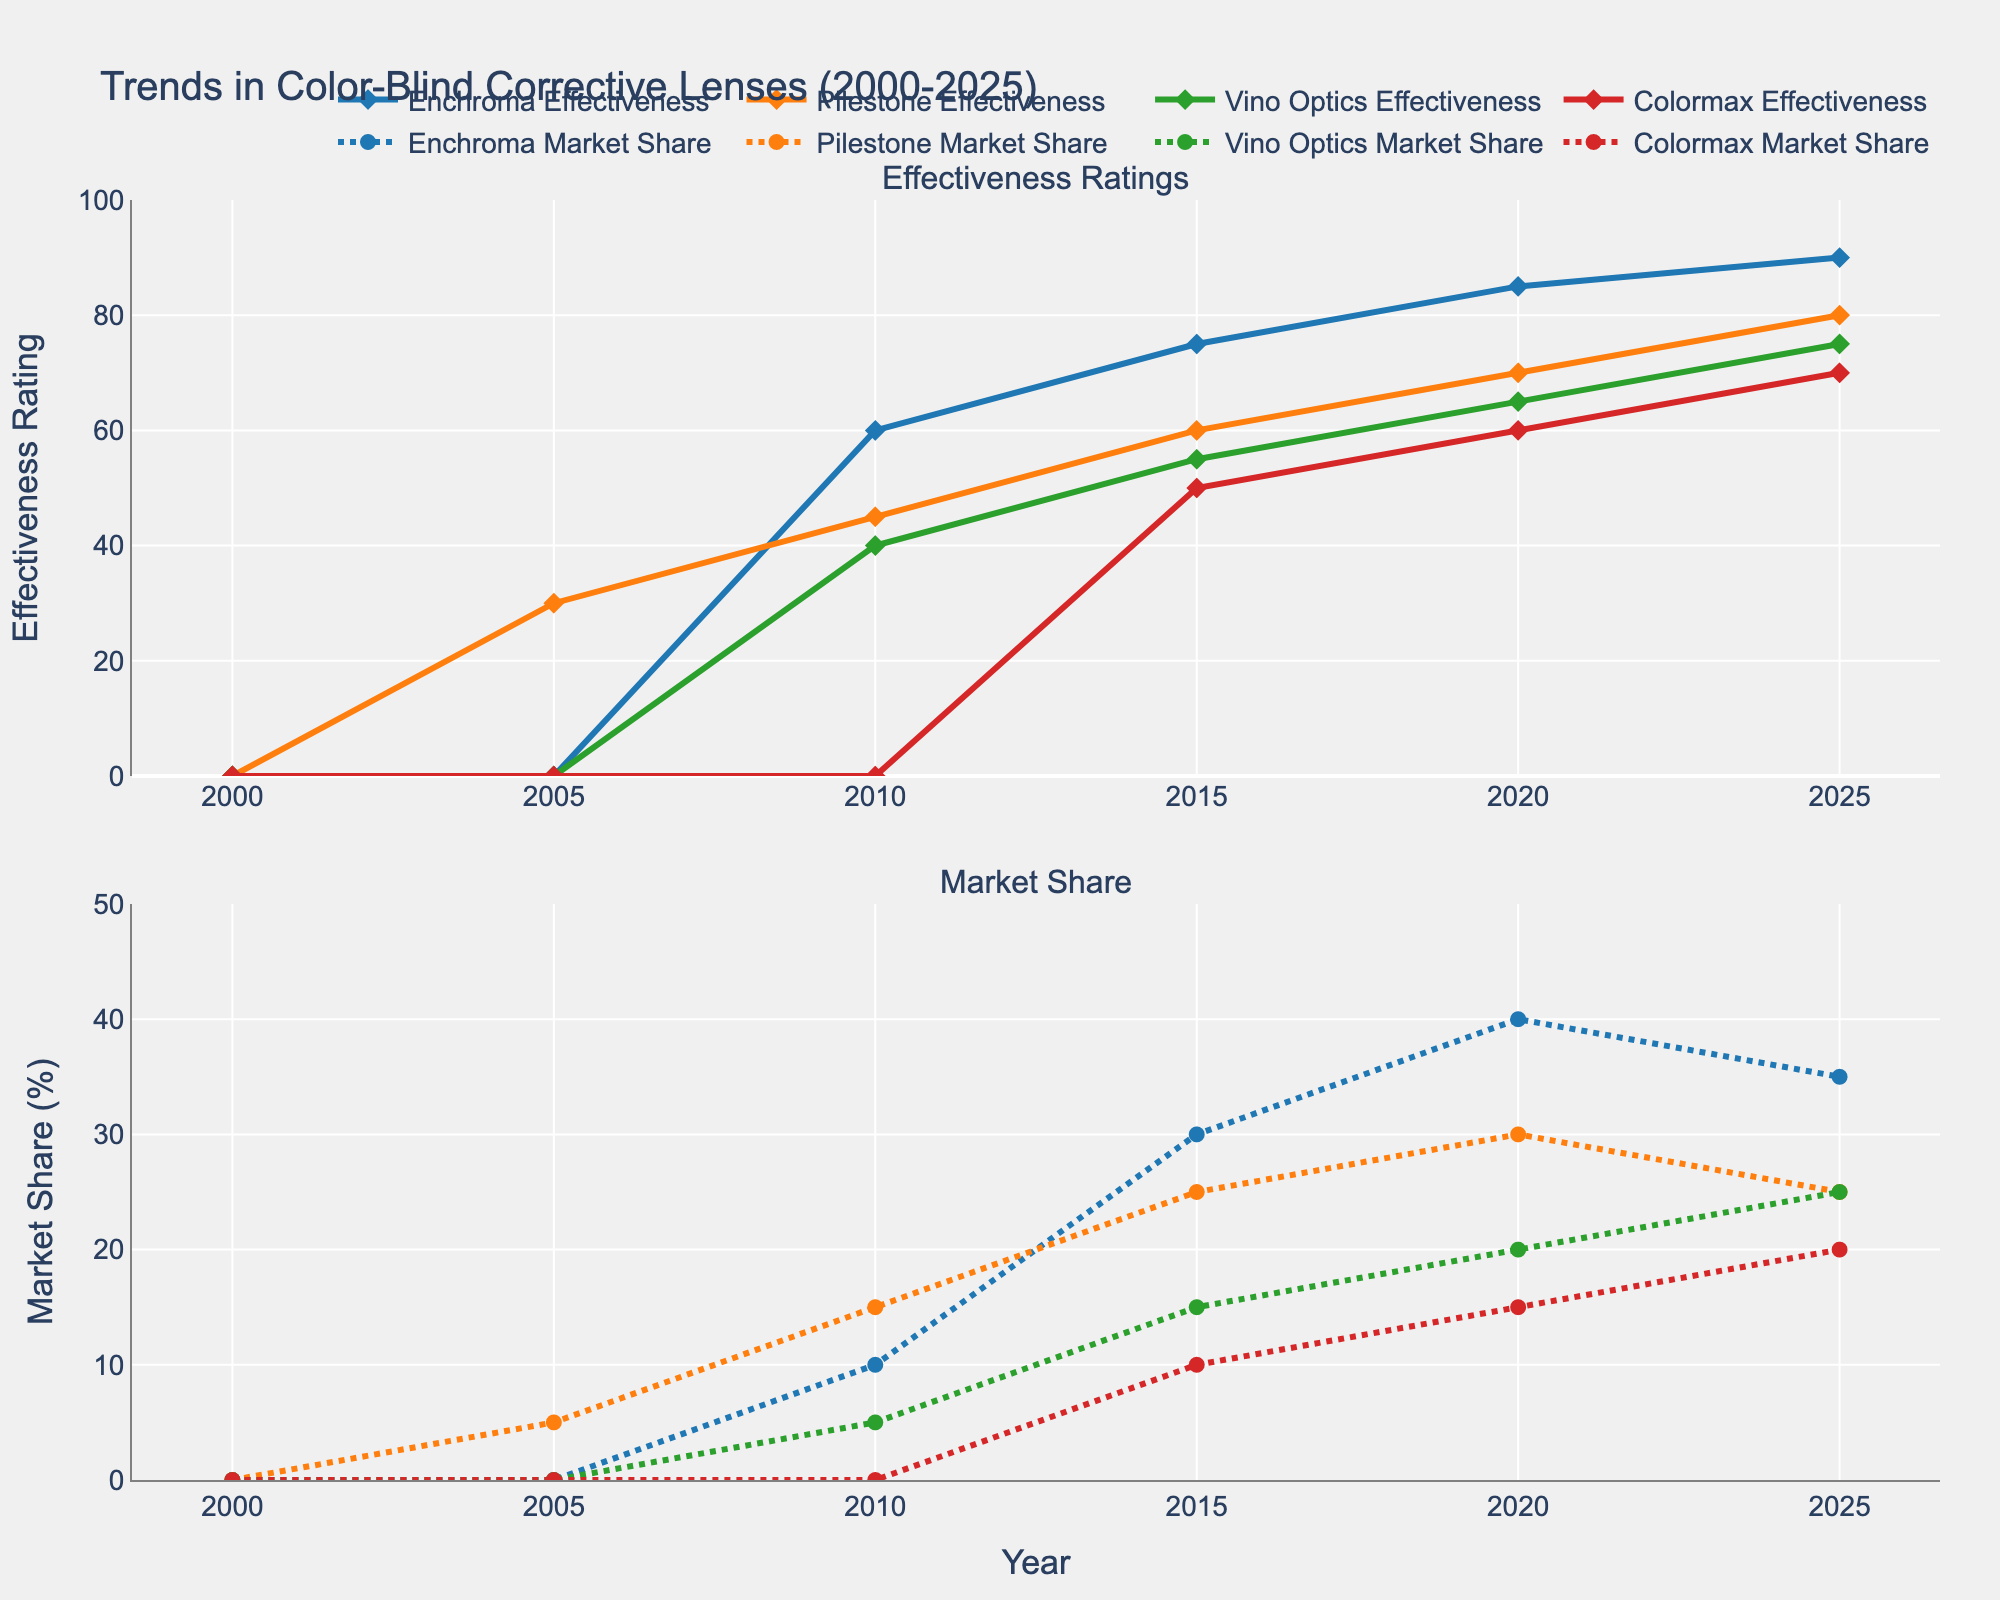What is the title of the figure? The title is displayed at the top of the figure and provides an overview of the content. The title given in the plot code is "Trends in Color-Blind Corrective Lenses (2000-2025)."
Answer: Trends in Color-Blind Corrective Lenses (2000-2025) How many subplots are present in the figure? The figure has titles for two different plots: "Effectiveness Ratings" and "Market Share," each positioned in separate sections.
Answer: 2 What is the Enchroma effectiveness rating in 2020? To determine this, locate the year 2020 on the x-axis of the Effectiveness Ratings subplot and find the corresponding point on the Enchroma line.
Answer: 85 Which brand shows a consistent increase in effectiveness from 2000 to 2025? By examining the Effectiveness Ratings subplot, we can see that Enchroma’s effectiveness rating consistently increases from 2000 to 2025.
Answer: Enchroma Which brand had the highest market share in 2015? On the Market Share subplot, find the year 2015 on the x-axis and compare the values for all brands. Enchroma has the highest percentage at 30%.
Answer: Enchroma What are the effectiveness ratings of all brands in 2025 summed together? Find each brand’s effectiveness rating for 2025 from the Effectiveness Ratings subplot and then sum them: Enchroma (90) + Pilestone (80) + Vino Optics (75) + Colormax (70).
Answer: 315 Which brand has the smallest increase in effectiveness from 2010 to 2015? Calculate the difference in effectiveness for each brand between 2010 and 2015 from the Effectiveness Ratings subplot. Colormax's effectiveness rises from 0 (in 2010) to 50 (in 2015), which is a smaller increase compared to other brands.
Answer: Colormax In which year did Vino Optics' market share equal Pilestone's market share? Look for the year where the Vino Optics and Pilestone lines intersect on the Market Share subplot. In 2025, both have a market share of 25%.
Answer: 2025 What is the combined market share percentage of Enchroma and Colormax in 2020? Add the market share percentages of Enchroma and Colormax from the Market Share subplot for 2020: Enchroma (40%) + Colormax (15%).
Answer: 55 Which brand saw an effectiveness rating above 50 for the first time in 2015? Check the Effectiveness Ratings subplot to see when each brand's rating exceeds 50. Vino Optics first exceeds 50 in 2015 with a rating of 55.
Answer: Vino Optics 